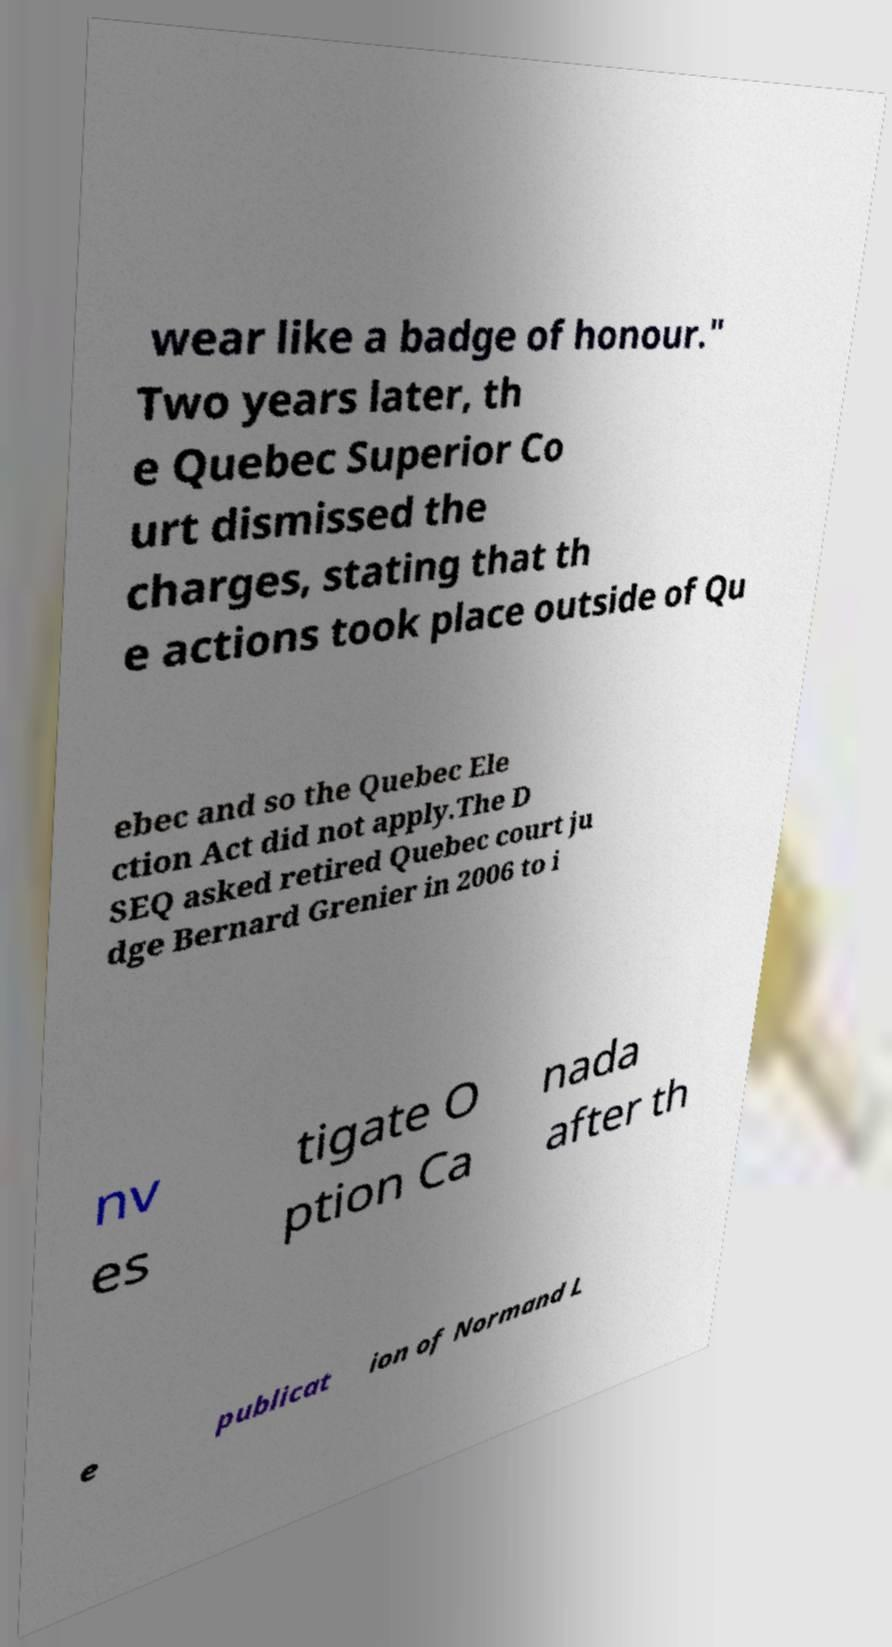Could you extract and type out the text from this image? wear like a badge of honour." Two years later, th e Quebec Superior Co urt dismissed the charges, stating that th e actions took place outside of Qu ebec and so the Quebec Ele ction Act did not apply.The D SEQ asked retired Quebec court ju dge Bernard Grenier in 2006 to i nv es tigate O ption Ca nada after th e publicat ion of Normand L 